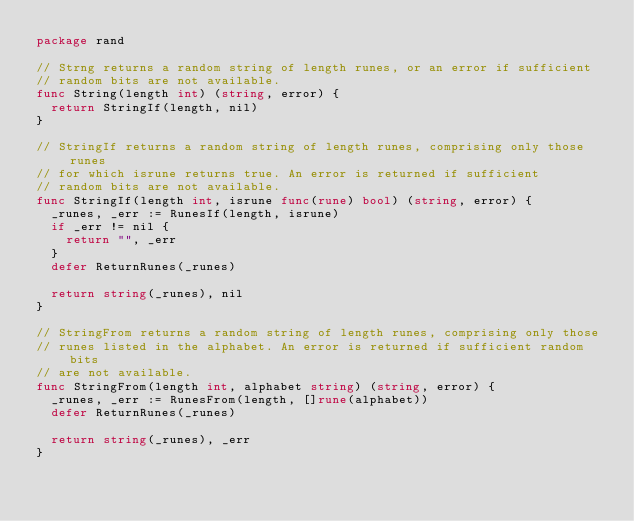Convert code to text. <code><loc_0><loc_0><loc_500><loc_500><_Go_>package rand

// Strng returns a random string of length runes, or an error if sufficient
// random bits are not available.
func String(length int) (string, error) {
	return StringIf(length, nil)
}

// StringIf returns a random string of length runes, comprising only those runes
// for which isrune returns true. An error is returned if sufficient
// random bits are not available.
func StringIf(length int, isrune func(rune) bool) (string, error) {
	_runes, _err := RunesIf(length, isrune)
	if _err != nil {
		return "", _err
	}
	defer ReturnRunes(_runes)

	return string(_runes), nil
}

// StringFrom returns a random string of length runes, comprising only those
// runes listed in the alphabet. An error is returned if sufficient random bits
// are not available.
func StringFrom(length int, alphabet string) (string, error) {
	_runes, _err := RunesFrom(length, []rune(alphabet))
	defer ReturnRunes(_runes)

	return string(_runes), _err
}
</code> 